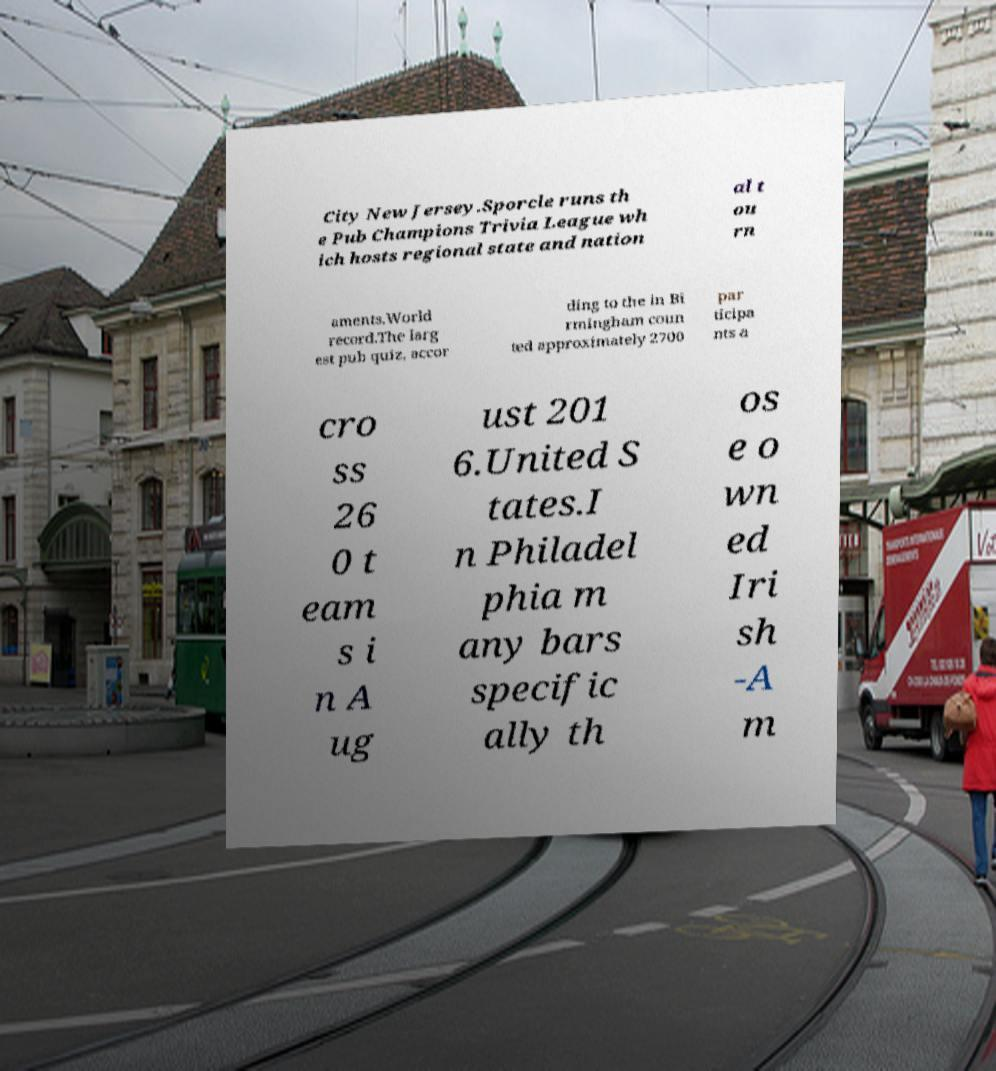Could you assist in decoding the text presented in this image and type it out clearly? City New Jersey.Sporcle runs th e Pub Champions Trivia League wh ich hosts regional state and nation al t ou rn aments.World record.The larg est pub quiz, accor ding to the in Bi rmingham coun ted approximately 2700 par ticipa nts a cro ss 26 0 t eam s i n A ug ust 201 6.United S tates.I n Philadel phia m any bars specific ally th os e o wn ed Iri sh -A m 